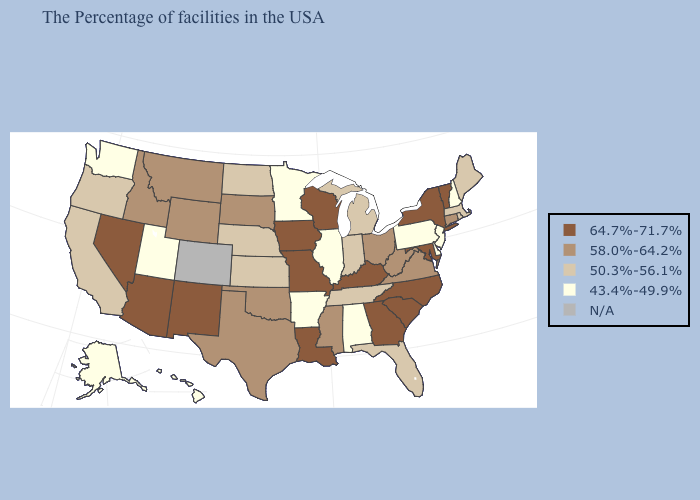Name the states that have a value in the range 50.3%-56.1%?
Short answer required. Maine, Massachusetts, Rhode Island, Florida, Michigan, Indiana, Tennessee, Kansas, Nebraska, North Dakota, California, Oregon. How many symbols are there in the legend?
Short answer required. 5. Name the states that have a value in the range N/A?
Write a very short answer. Colorado. Name the states that have a value in the range 64.7%-71.7%?
Keep it brief. Vermont, New York, Maryland, North Carolina, South Carolina, Georgia, Kentucky, Wisconsin, Louisiana, Missouri, Iowa, New Mexico, Arizona, Nevada. Name the states that have a value in the range 50.3%-56.1%?
Answer briefly. Maine, Massachusetts, Rhode Island, Florida, Michigan, Indiana, Tennessee, Kansas, Nebraska, North Dakota, California, Oregon. What is the value of Florida?
Write a very short answer. 50.3%-56.1%. What is the value of Missouri?
Answer briefly. 64.7%-71.7%. Name the states that have a value in the range N/A?
Short answer required. Colorado. What is the lowest value in the USA?
Short answer required. 43.4%-49.9%. What is the value of Iowa?
Keep it brief. 64.7%-71.7%. What is the highest value in the USA?
Be succinct. 64.7%-71.7%. What is the lowest value in the West?
Be succinct. 43.4%-49.9%. What is the value of Wisconsin?
Answer briefly. 64.7%-71.7%. 